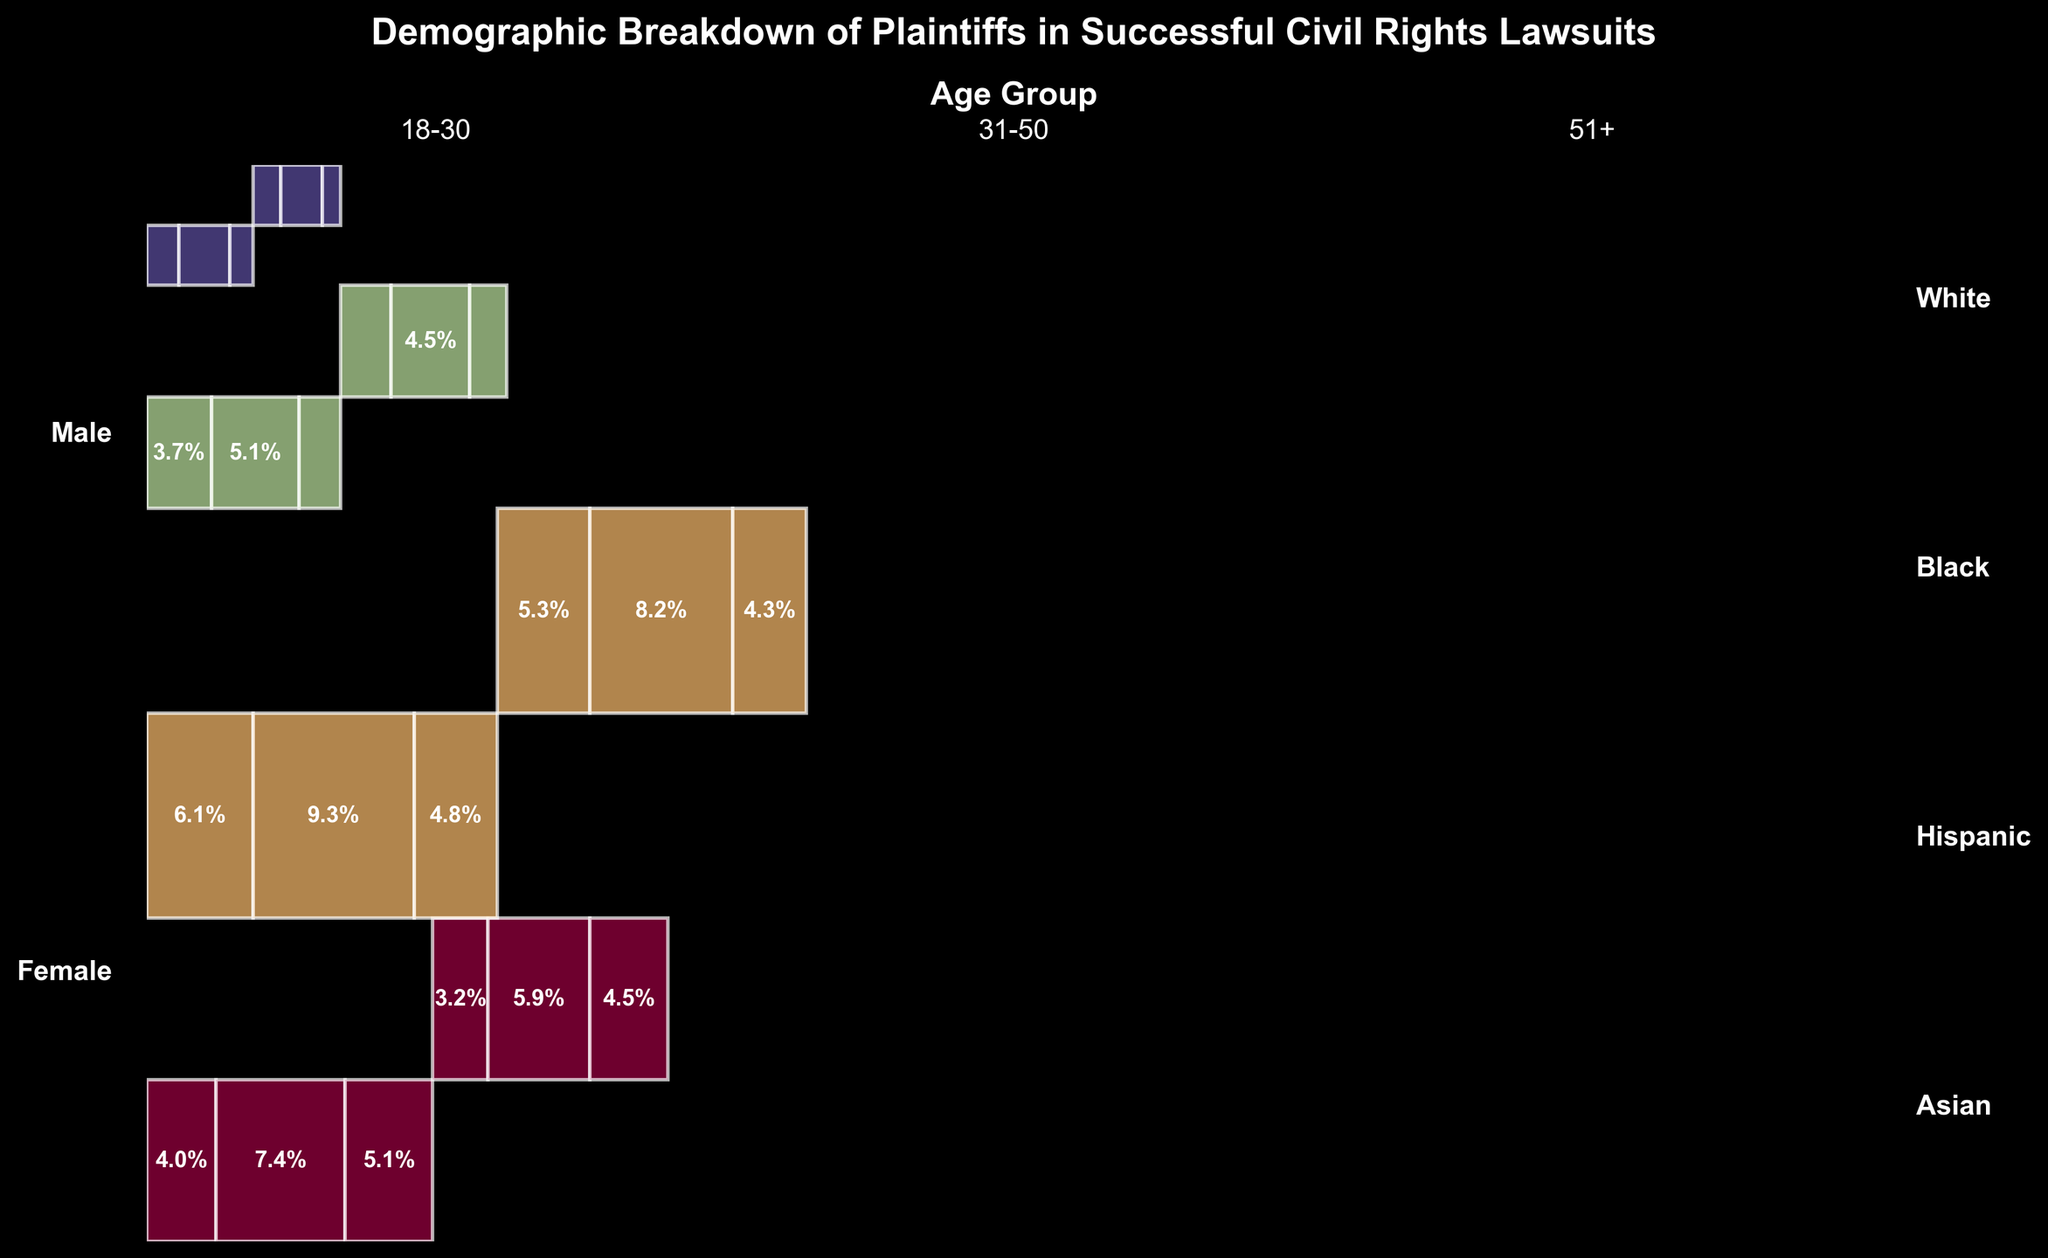What is the title of the figure? The title of the figure is located at the top of the plot in bold, which summarizes the content of the plot.
Answer: Demographic Breakdown of Plaintiffs in Successful Civil Rights Lawsuits Which race has the highest proportion of successful plaintiffs? By visually comparing the total height of sections for each race, we can see that the sections for Black plaintiffs are the tallest.
Answer: Black How does the proportion of successful White male plaintiffs aged 31-50 compare to White female plaintiffs in the same age group? To answer this, observe the widths of the rectangular sections for White males and females in the 31-50 age group. The width for White males is greater than that for White females.
Answer: Greater Which gender has the higher proportion of successful plaintiffs within the Hispanic race? By comparing the combined width of rectangles for Hispanic males vs. Hispanic females, we note that the width for males is slightly greater.
Answer: Male What age group has the smallest proportion of successful Asian female plaintiffs? Examine the widths of rectangles for Asian females across all age groups. The rectangle for the 51+ age group is the narrowest.
Answer: 51+ How similar are the proportions of successful Black female plaintiffs aged 18-30 and 31-50? By comparing the widths of the rectangles for the two age groups of Black females, we see they are relatively close in width, indicating similar proportions.
Answer: Similar What is the combined proportion of successful plaintiffs who are White males aged either 18-30 or 51+? Add the widths of the rectangles corresponding to White males aged 18-30 and 51+. The combined width will show the proportion.
Answer: 15/230 + 19/230 ≈ 14.8% Are Black female plaintiffs in the 31-50 age group more or less represented than White plaintiffs (both genders) in the same age group? Compare the total width of the rectangles for White plaintiffs aged 31-50 (both genders) against the rectangle for Black female plaintiffs aged 31-50. The combined width for White plaintiffs (0.2174) is less than the width for Black female plaintiffs (0.1348).
Answer: Less Which race and gender combination is least represented among successful plaintiffs aged 18-30? Compare the widths of all rectangles corresponding to the 18-30 age group. Asian female 18-30 has the smallest width.
Answer: Asian Female What is the total proportion of successful Hispanic plaintiffs in all age groups? Sum the widths of all rectangles for Hispanic plaintiffs across all age groups and genders. Sum up (14+11+19+17+9+8)/230.
Answer: 0.34 